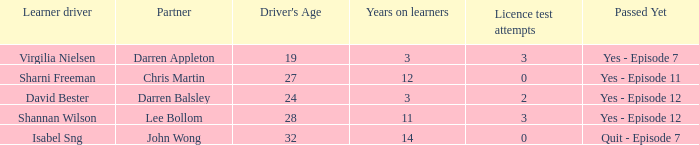What is the average number of years on learners of the drivers over the age of 24 with less than 0 attempts at the licence test? None. 